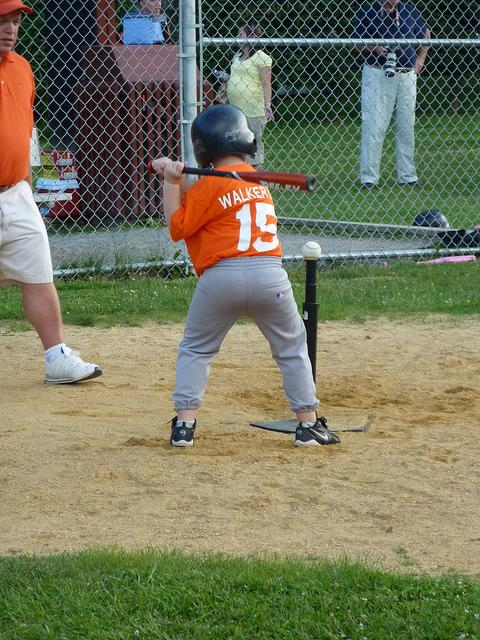What is this kid playing in? sand 